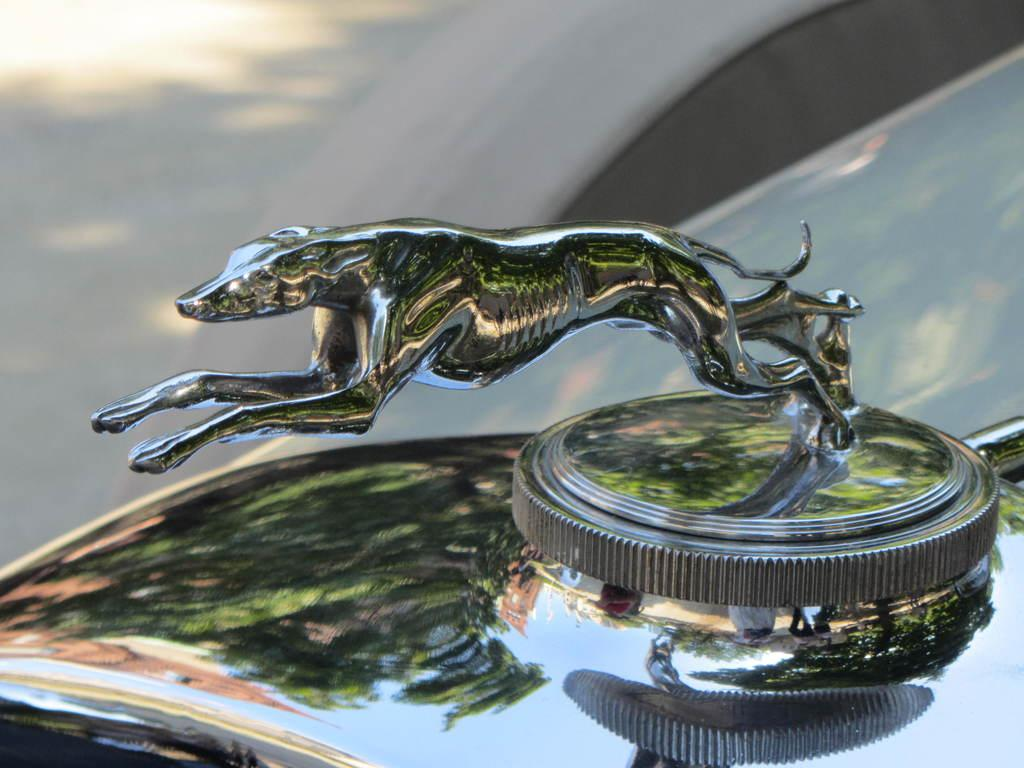What is the main subject of the image? The main subject of the image is a car. Can you describe the color of the car? The car is black. What additional detail can be seen on the car? There is a symbol of an animal on the car. How would you describe the background of the image? The background of the image is blurry. What type of nut is being used to plough the field in the image? There is no nut or plough present in the image; it features a black car with an animal symbol. 